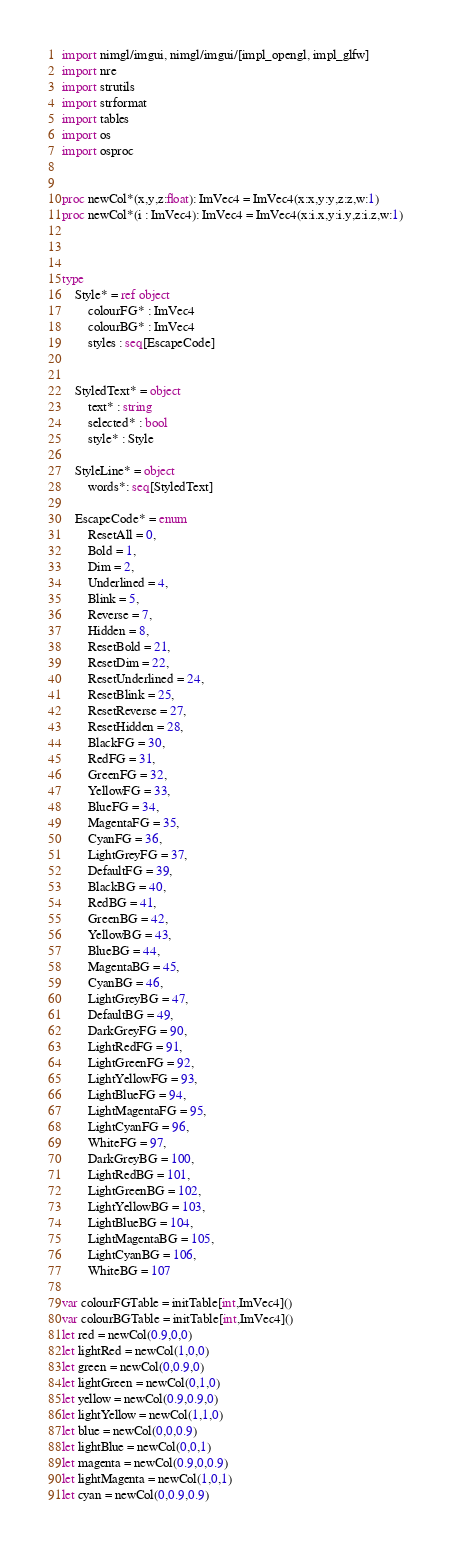Convert code to text. <code><loc_0><loc_0><loc_500><loc_500><_Nim_>import nimgl/imgui, nimgl/imgui/[impl_opengl, impl_glfw]
import nre
import strutils
import strformat
import tables
import os
import osproc


proc newCol*(x,y,z:float): ImVec4 = ImVec4(x:x,y:y,z:z,w:1)
proc newCol*(i : ImVec4): ImVec4 = ImVec4(x:i.x,y:i.y,z:i.z,w:1)



type
    Style* = ref object
        colourFG* : ImVec4
        colourBG* : ImVec4
        styles : seq[EscapeCode]


    StyledText* = object
        text* : string
        selected* : bool
        style* : Style

    StyleLine* = object
        words*: seq[StyledText]

    EscapeCode* = enum
        ResetAll = 0,
        Bold = 1,
        Dim = 2,
        Underlined = 4,
        Blink = 5,
        Reverse = 7,
        Hidden = 8,
        ResetBold = 21,
        ResetDim = 22,
        ResetUnderlined = 24,
        ResetBlink = 25,
        ResetReverse = 27,
        ResetHidden = 28,
        BlackFG = 30,
        RedFG = 31,
        GreenFG = 32,
        YellowFG = 33,
        BlueFG = 34,
        MagentaFG = 35,
        CyanFG = 36,
        LightGreyFG = 37,
        DefaultFG = 39,
        BlackBG = 40,
        RedBG = 41,
        GreenBG = 42,
        YellowBG = 43,
        BlueBG = 44,
        MagentaBG = 45,
        CyanBG = 46,
        LightGreyBG = 47,
        DefaultBG = 49,
        DarkGreyFG = 90,
        LightRedFG = 91,
        LightGreenFG = 92,
        LightYellowFG = 93,
        LightBlueFG = 94,
        LightMagentaFG = 95,
        LightCyanFG = 96,
        WhiteFG = 97,
        DarkGreyBG = 100,
        LightRedBG = 101,
        LightGreenBG = 102,
        LightYellowBG = 103,
        LightBlueBG = 104,
        LightMagentaBG = 105,
        LightCyanBG = 106,
        WhiteBG = 107

var colourFGTable = initTable[int,ImVec4]()
var colourBGTable = initTable[int,ImVec4]()
let red = newCol(0.9,0,0)
let lightRed = newCol(1,0,0)
let green = newCol(0,0.9,0)
let lightGreen = newCol(0,1,0)
let yellow = newCol(0.9,0.9,0)
let lightYellow = newCol(1,1,0)
let blue = newCol(0,0,0.9)
let lightBlue = newCol(0,0,1)
let magenta = newCol(0.9,0,0.9)
let lightMagenta = newCol(1,0,1)
let cyan = newCol(0,0.9,0.9)</code> 